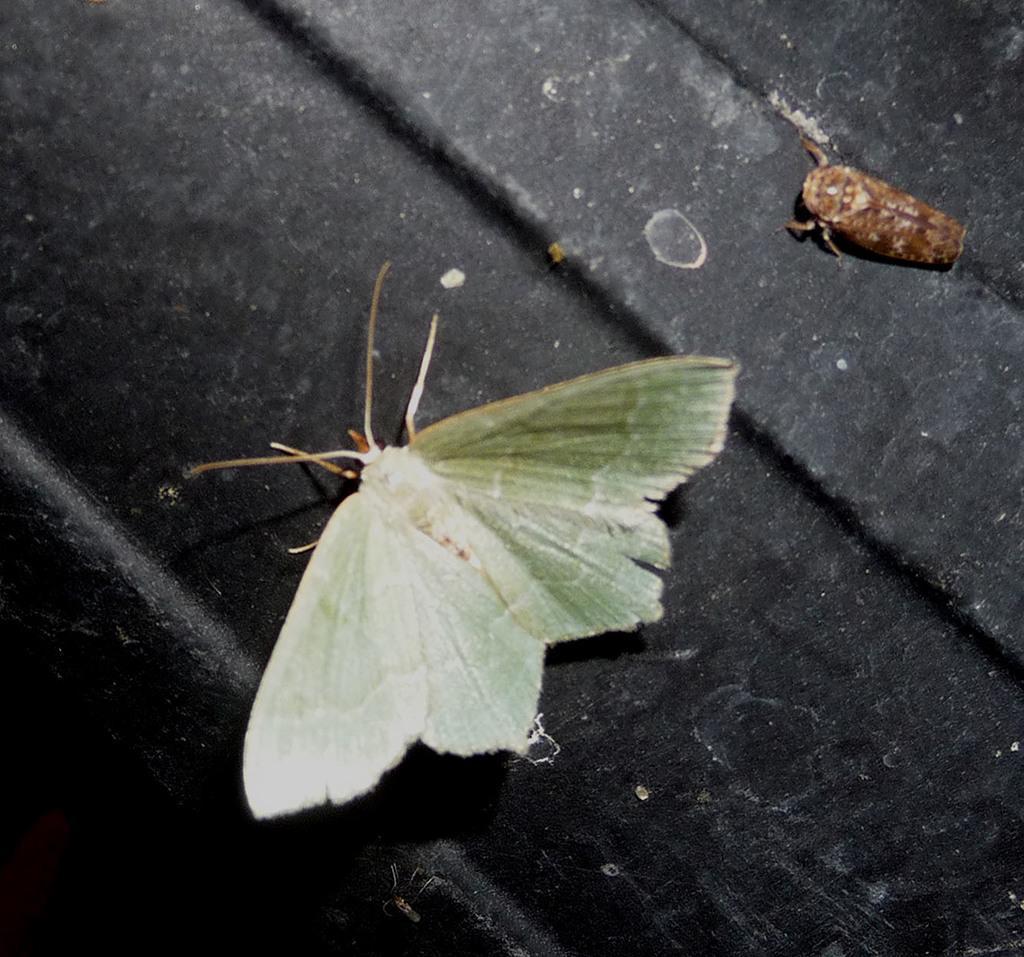Can you describe this image briefly? In this picture I can see a moth and an insect on the black color surface. 